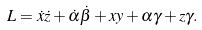Convert formula to latex. <formula><loc_0><loc_0><loc_500><loc_500>L = \dot { x } \dot { z } + \dot { \alpha } \dot { \beta } + x y + \alpha \gamma + z \gamma .</formula> 